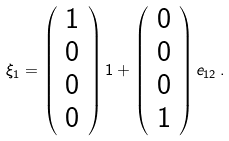<formula> <loc_0><loc_0><loc_500><loc_500>\xi _ { 1 } = \left ( \begin{array} { c } 1 \\ 0 \\ 0 \\ 0 \end{array} \right ) 1 + \left ( \begin{array} { c } 0 \\ 0 \\ 0 \\ 1 \end{array} \right ) e _ { 1 2 } \, .</formula> 